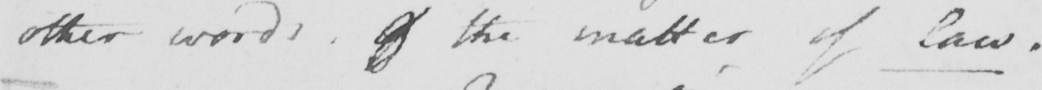Transcribe the text shown in this historical manuscript line. other words of the matter of Law 